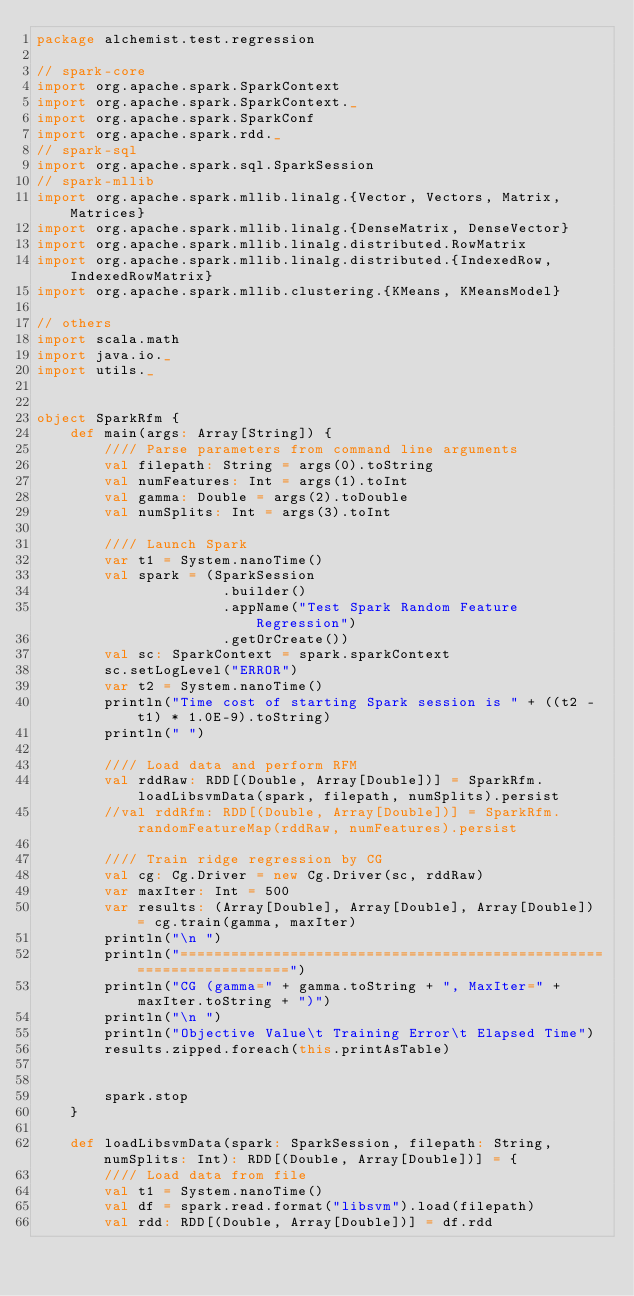Convert code to text. <code><loc_0><loc_0><loc_500><loc_500><_Scala_>package alchemist.test.regression

// spark-core
import org.apache.spark.SparkContext
import org.apache.spark.SparkContext._
import org.apache.spark.SparkConf
import org.apache.spark.rdd._
// spark-sql
import org.apache.spark.sql.SparkSession
// spark-mllib
import org.apache.spark.mllib.linalg.{Vector, Vectors, Matrix, Matrices}
import org.apache.spark.mllib.linalg.{DenseMatrix, DenseVector}
import org.apache.spark.mllib.linalg.distributed.RowMatrix
import org.apache.spark.mllib.linalg.distributed.{IndexedRow, IndexedRowMatrix}
import org.apache.spark.mllib.clustering.{KMeans, KMeansModel}

// others
import scala.math
import java.io._
import utils._


object SparkRfm {
    def main(args: Array[String]) {
        //// Parse parameters from command line arguments
        val filepath: String = args(0).toString
        val numFeatures: Int = args(1).toInt
        val gamma: Double = args(2).toDouble
        val numSplits: Int = args(3).toInt
        
        //// Launch Spark
        var t1 = System.nanoTime()
        val spark = (SparkSession
                      .builder()
                      .appName("Test Spark Random Feature Regression")
                      .getOrCreate())
        val sc: SparkContext = spark.sparkContext
        sc.setLogLevel("ERROR")
        var t2 = System.nanoTime()
        println("Time cost of starting Spark session is " + ((t2 - t1) * 1.0E-9).toString)
        println(" ")
        
        //// Load data and perform RFM
        val rddRaw: RDD[(Double, Array[Double])] = SparkRfm.loadLibsvmData(spark, filepath, numSplits).persist
        //val rddRfm: RDD[(Double, Array[Double])] = SparkRfm.randomFeatureMap(rddRaw, numFeatures).persist
        
        //// Train ridge regression by CG
        val cg: Cg.Driver = new Cg.Driver(sc, rddRaw)
        var maxIter: Int = 500
        var results: (Array[Double], Array[Double], Array[Double]) = cg.train(gamma, maxIter)
        println("\n ")
        println("====================================================================")
        println("CG (gamma=" + gamma.toString + ", MaxIter=" + maxIter.toString + ")")
        println("\n ")
        println("Objective Value\t Training Error\t Elapsed Time")
        results.zipped.foreach(this.printAsTable)

        
        spark.stop
    }
    
    def loadLibsvmData(spark: SparkSession, filepath: String, numSplits: Int): RDD[(Double, Array[Double])] = {
        //// Load data from file
        val t1 = System.nanoTime()
        val df = spark.read.format("libsvm").load(filepath)
        val rdd: RDD[(Double, Array[Double])] = df.rdd</code> 